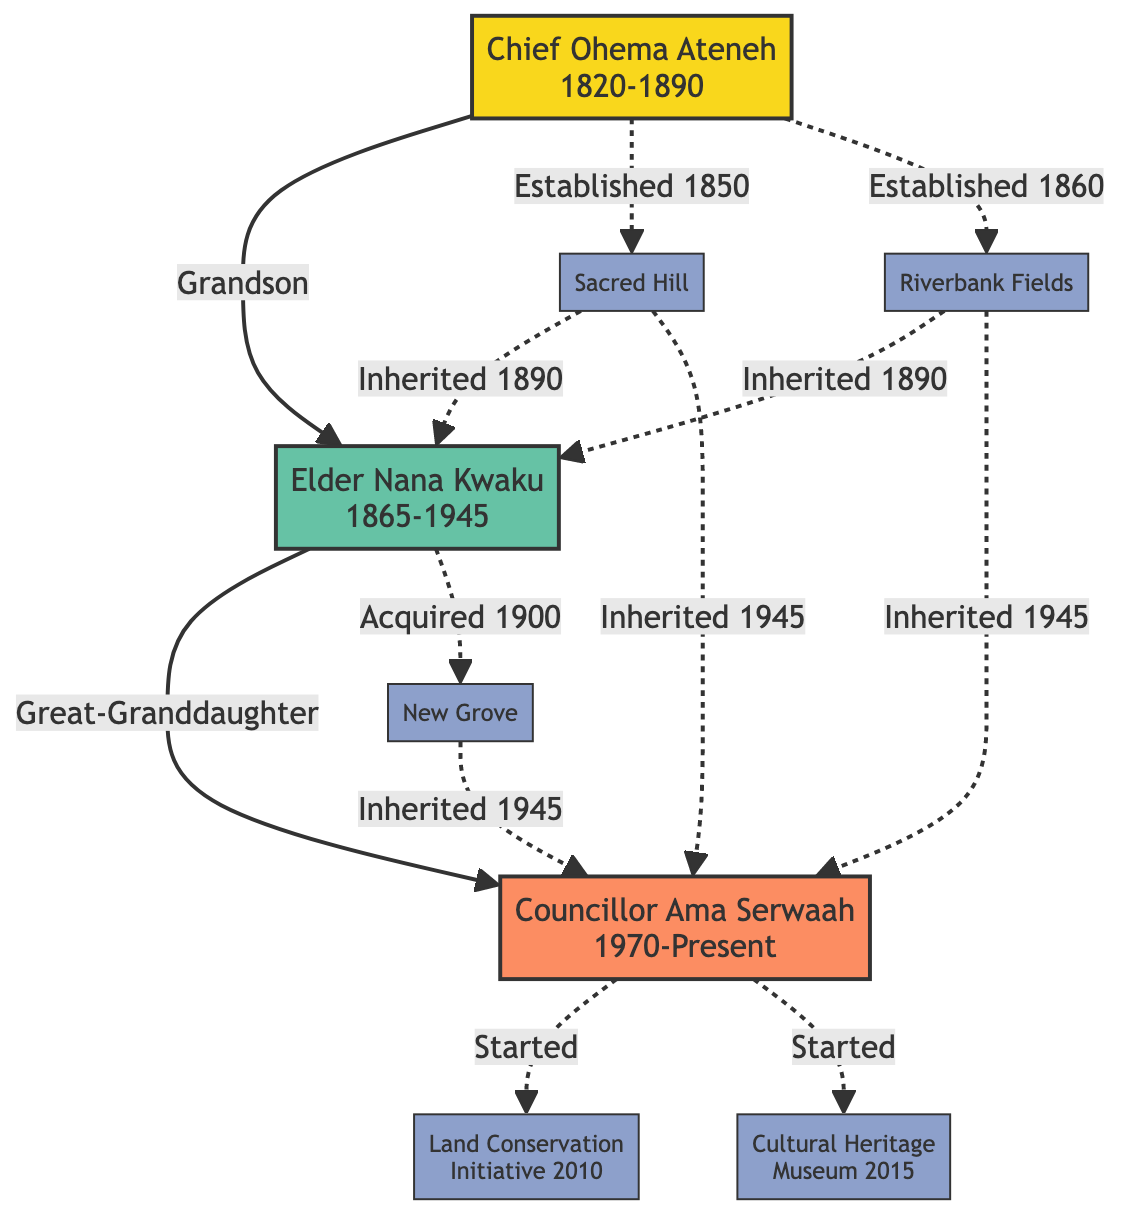What is the birth year of Chief Ohema Ateneh? The diagram indicates that Chief Ohema Ateneh was born in the year 1820, which can be seen in his node.
Answer: 1820 How many significant events are listed for Elder Nana Kwaku? Looking at the node for Elder Nana Kwaku, there are two significant events mentioned, which can be counted directly.
Answer: 2 Who is the current generation representative in the family tree? The node representing the current generation is Councillor Ama Serwaah, identified by the label in the diagram.
Answer: Councillor Ama Serwaah What land did Councillor Ama Serwaah inherit in 1945? The diagram shows three lands inherited by Councillor Ama Serwaah in 1945: Sacred Hill, Riverbank Fields, and New Grove, which can be verified by examining the inherited land section in her node.
Answer: Sacred Hill, Riverbank Fields, New Grove Which ancestor negotiated a peace treaty with a neighboring tribe? The node for Chief Ohema Ateneh states that he negotiated a peace treaty with a neighboring tribe, extracted directly from his significant events.
Answer: Chief Ohema Ateneh What land was acquired by Elder Nana Kwaku in 1900? In the diagram, it is noted that Elder Nana Kwaku acquired New Grove in 1900, which can be found under his land owned section.
Answer: New Grove How is Councillor Ama Serwaah related to Chief Ohema Ateneh? By tracing the relationships in the diagram, Councillor Ama Serwaah is identified as the great-granddaughter of Elder Nana Kwaku, and hence is the great-granddaughter of Chief Ohema Ateneh through that lineage.
Answer: Great-Granddaughter What project did Councillor Ama Serwaah start in 2015? The diagram highlights that Councillor Ama Serwaah started the Cultural Heritage Museum in 2015, indicated in her new contributions.
Answer: Cultural Heritage Museum How many ancestors are represented in the family tree? The family tree has one ancestor, Chief Ohema Ateneh, as shown in the ancestor section of the diagram.
Answer: 1 